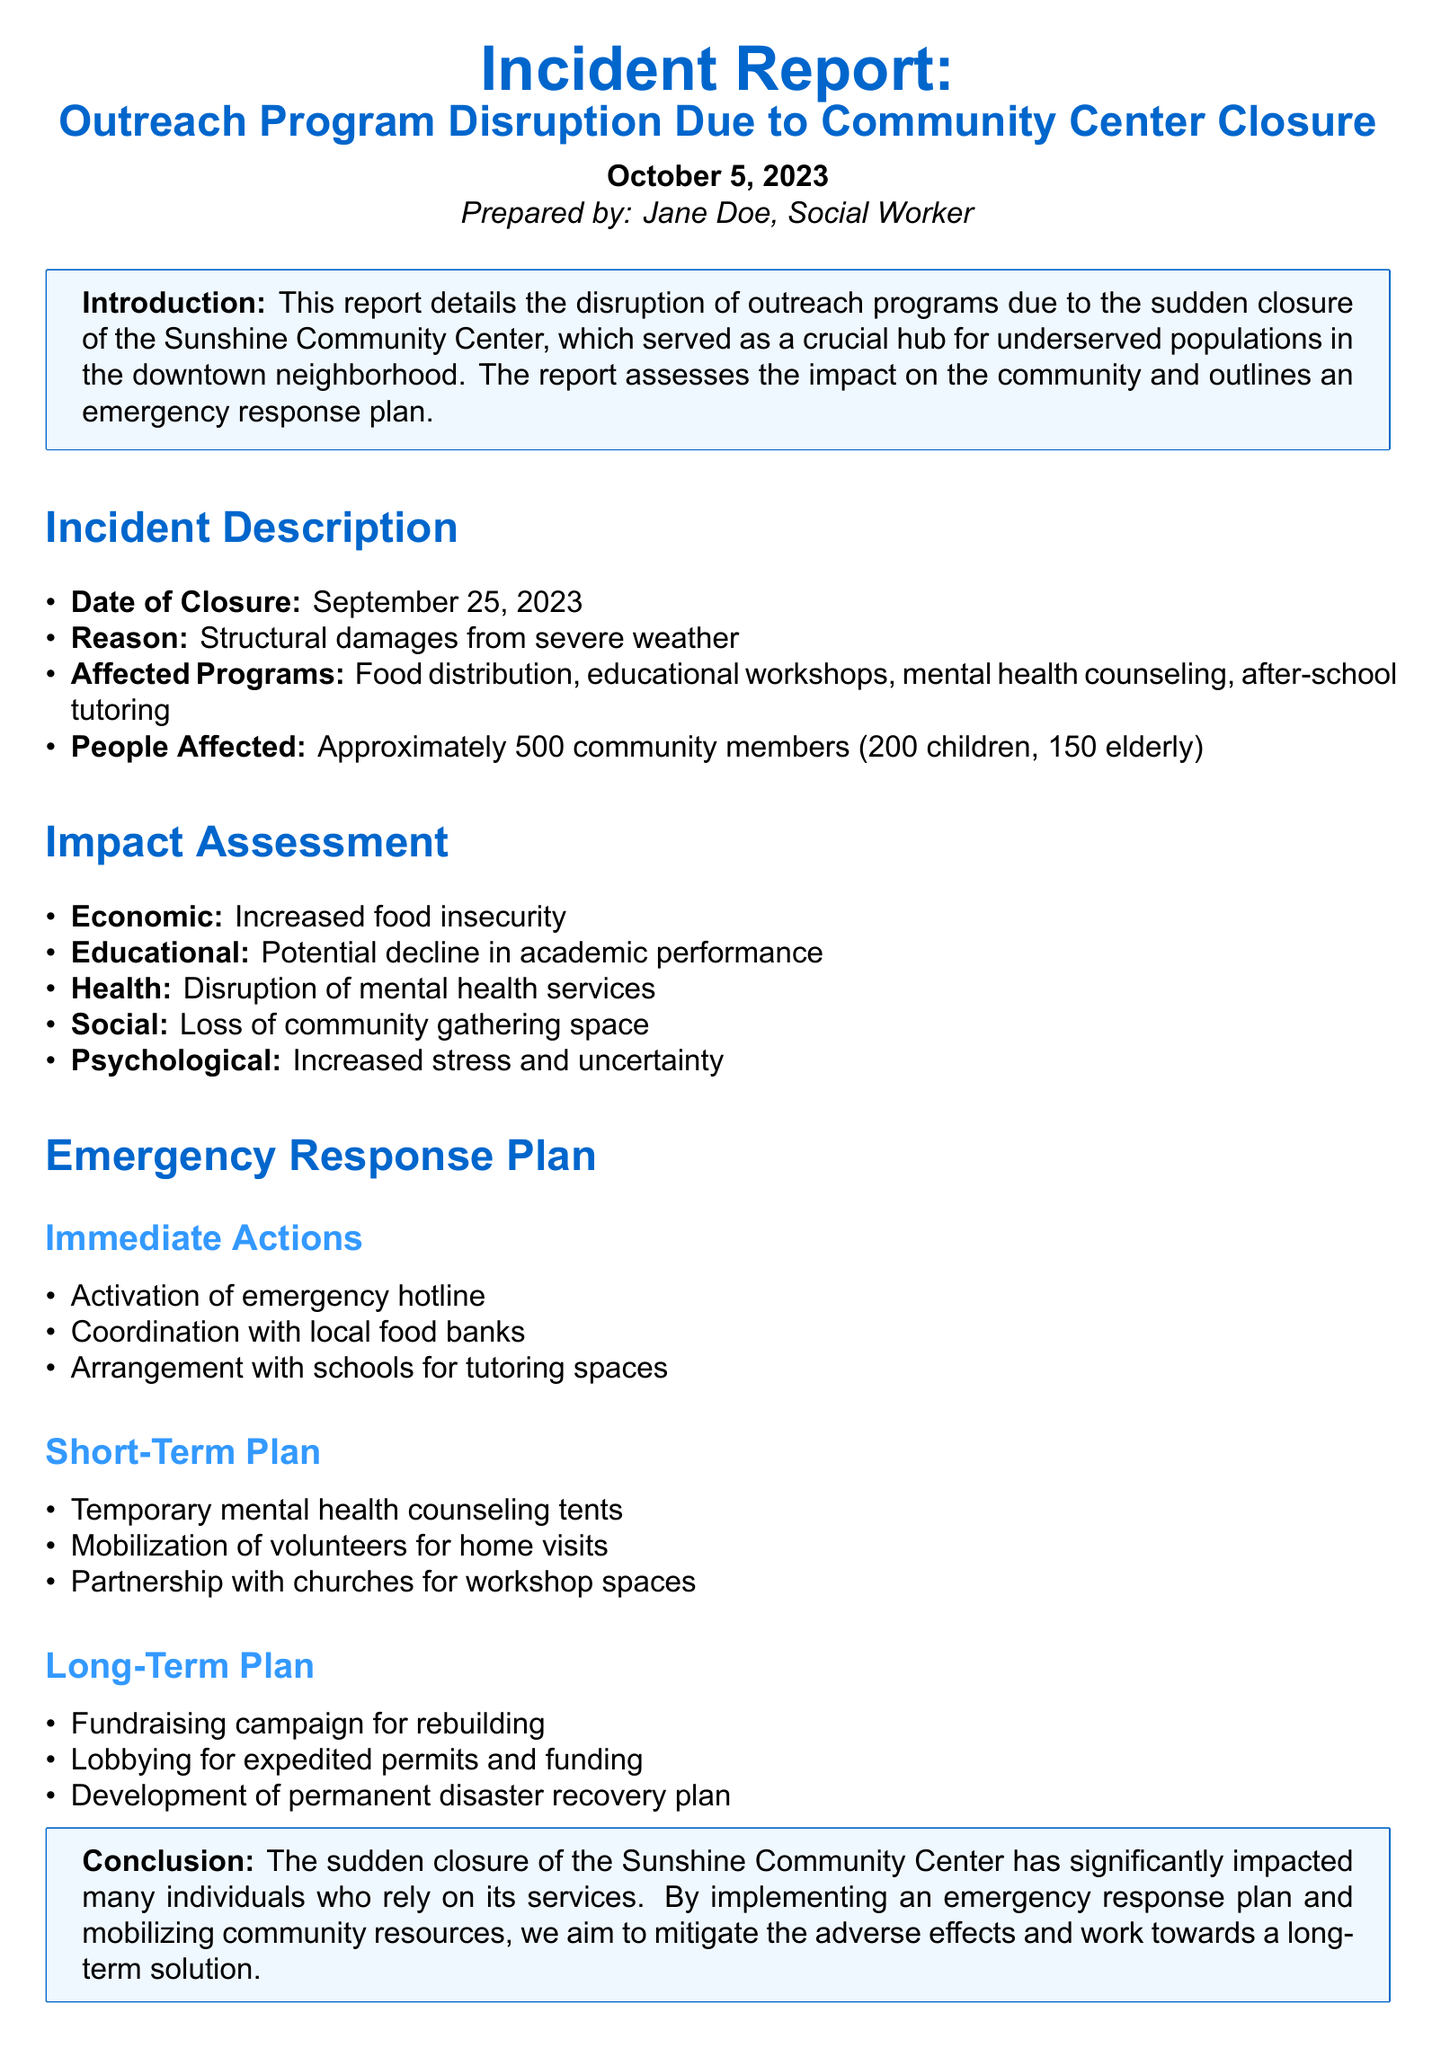what was the date of the community center closure? The date of closure is explicitly mentioned in the document as September 25, 2023.
Answer: September 25, 2023 what programs were affected by the community center closure? The affected programs are listed in the incident description, which includes food distribution, educational workshops, mental health counseling, and after-school tutoring.
Answer: Food distribution, educational workshops, mental health counseling, after-school tutoring how many community members were affected? The number of affected community members is specified in the incident description as approximately 500.
Answer: Approximately 500 what is one psychological impact of the community center closure? The document outlines several impacts, and one psychological impact mentioned is increased stress and uncertainty.
Answer: Increased stress and uncertainty what is one immediate action from the emergency response plan? The immediate actions are detailed in the document, one of which is the activation of an emergency hotline.
Answer: Activation of emergency hotline how many children were affected by the closure? The document specifically states that 200 children were affected by the closure.
Answer: 200 children what does the short-term plan include? The short-term plan lists several actions; one of them is the temporary mental health counseling tents.
Answer: Temporary mental health counseling tents who prepared the report? The report clearly identifies Jane Doe as the preparer.
Answer: Jane Doe 